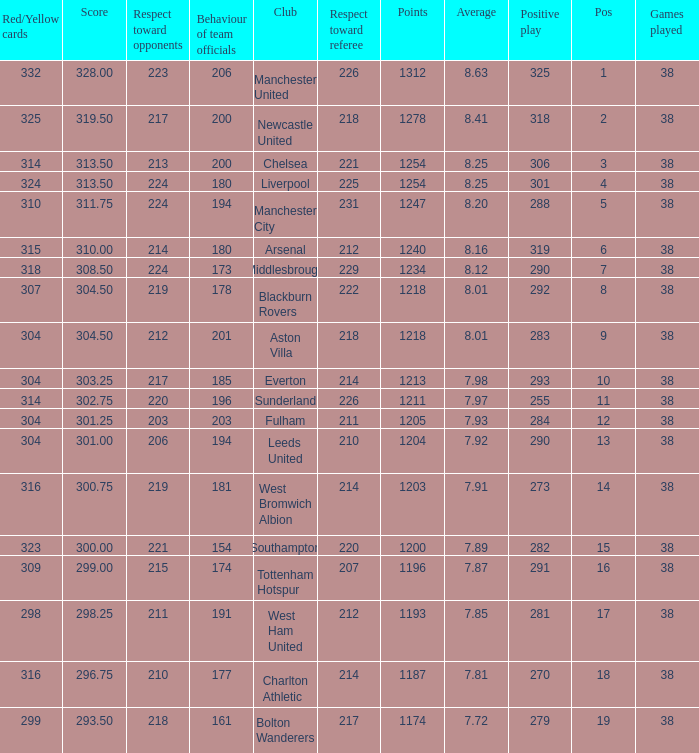Name the most red/yellow cards for positive play being 255 314.0. 